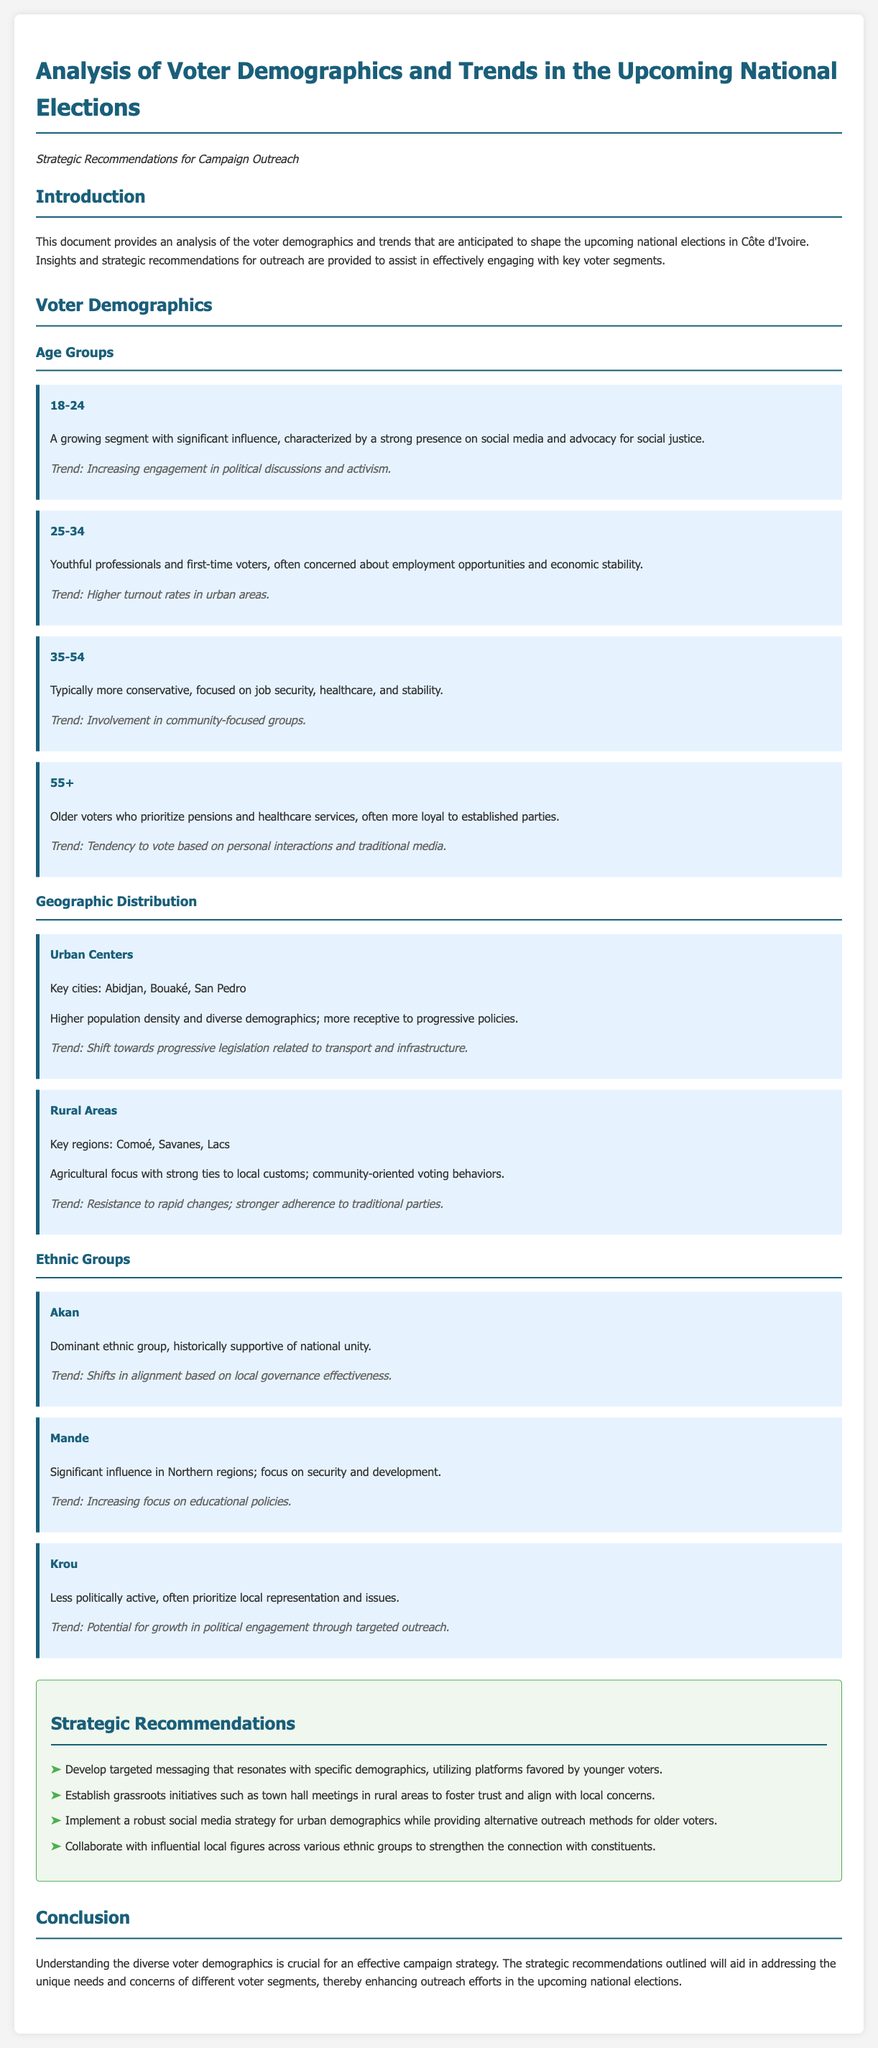What are the key cities in urban centers? The document lists Abidjan, Bouaké, and San Pedro as key cities in urban centers.
Answer: Abidjan, Bouaké, San Pedro Which age group is characterized by strong presence on social media? The 18-24 age group is noted for its significant influence and strong presence on social media.
Answer: 18-24 What issues do the 35-54 age group focus on? The 35-54 age group typically focuses on job security, healthcare, and stability.
Answer: Job security, healthcare, and stability What trend is associated with the Akan ethnic group? The Akan ethnic group's trend is towards shifts in alignment based on local governance effectiveness.
Answer: Shifts in alignment based on local governance effectiveness What strategic recommendation involves grassroots initiatives? The recommendation suggests establishing grassroots initiatives such as town hall meetings in rural areas.
Answer: Grassroots initiatives What demographic shows a higher turnout rate in urban areas? The 25-34 age group is noted for higher turnout rates in urban areas.
Answer: 25-34 What is the primary concern for voters in rural areas? Voters in rural areas are focused on local customs and community-oriented voting behaviors.
Answer: Local customs and community-oriented voting behaviors Which demographic is often more loyal to established parties? Voters aged 55 and older are often described as being more loyal to established parties.
Answer: 55+ What type of media do older voters tend to vote based on? Older voters tend to vote based on personal interactions and traditional media.
Answer: Personal interactions and traditional media 